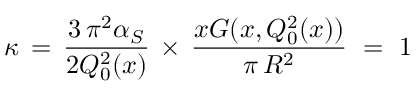<formula> <loc_0><loc_0><loc_500><loc_500>\kappa \, = \, \frac { 3 \, \pi ^ { 2 } \alpha _ { S } } { 2 Q _ { 0 } ^ { 2 } ( x ) } \, \times \, \frac { x G ( x , Q _ { 0 } ^ { 2 } ( x ) ) } { \pi \, R ^ { 2 } } \, = \, 1</formula> 